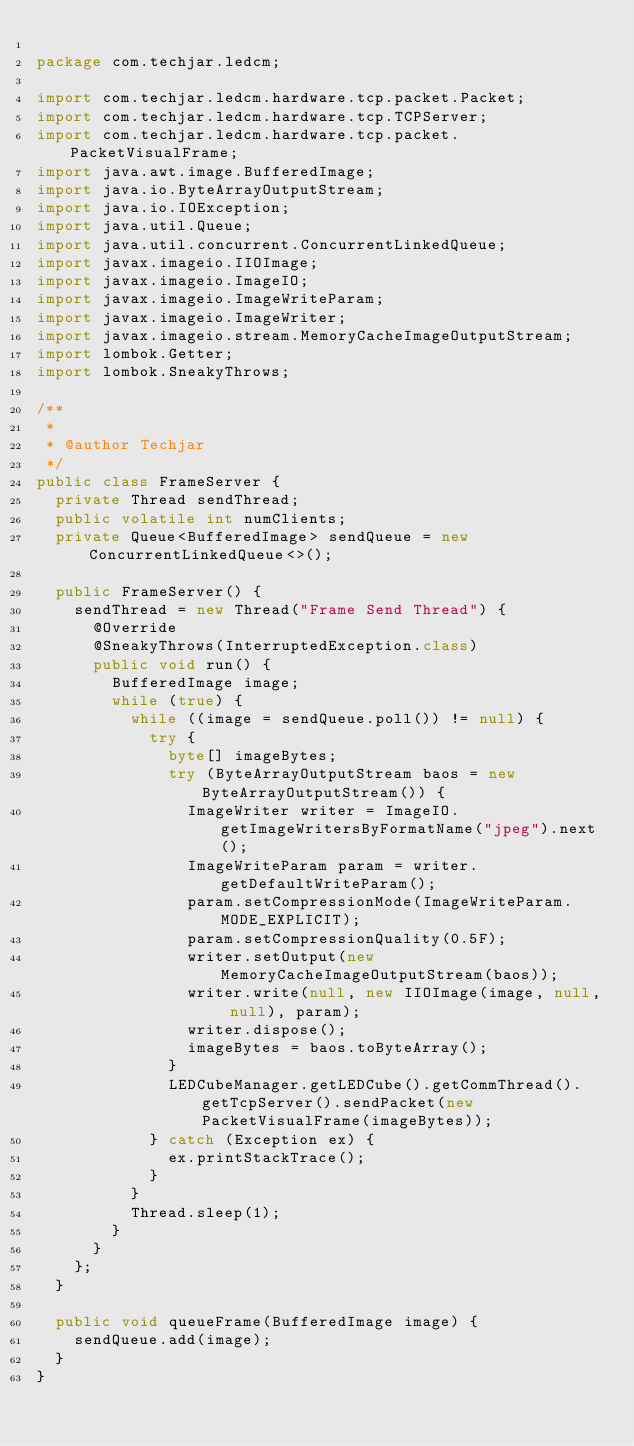Convert code to text. <code><loc_0><loc_0><loc_500><loc_500><_Java_>
package com.techjar.ledcm;

import com.techjar.ledcm.hardware.tcp.packet.Packet;
import com.techjar.ledcm.hardware.tcp.TCPServer;
import com.techjar.ledcm.hardware.tcp.packet.PacketVisualFrame;
import java.awt.image.BufferedImage;
import java.io.ByteArrayOutputStream;
import java.io.IOException;
import java.util.Queue;
import java.util.concurrent.ConcurrentLinkedQueue;
import javax.imageio.IIOImage;
import javax.imageio.ImageIO;
import javax.imageio.ImageWriteParam;
import javax.imageio.ImageWriter;
import javax.imageio.stream.MemoryCacheImageOutputStream;
import lombok.Getter;
import lombok.SneakyThrows;

/**
 *
 * @author Techjar
 */
public class FrameServer {
	private Thread sendThread;
	public volatile int numClients;
	private Queue<BufferedImage> sendQueue = new ConcurrentLinkedQueue<>();

	public FrameServer() {
		sendThread = new Thread("Frame Send Thread") {
			@Override
			@SneakyThrows(InterruptedException.class)
			public void run() {
				BufferedImage image;
				while (true) {
					while ((image = sendQueue.poll()) != null) {
						try {
							byte[] imageBytes;
							try (ByteArrayOutputStream baos = new ByteArrayOutputStream()) {
								ImageWriter writer = ImageIO.getImageWritersByFormatName("jpeg").next();
								ImageWriteParam param = writer.getDefaultWriteParam();
								param.setCompressionMode(ImageWriteParam.MODE_EXPLICIT);
								param.setCompressionQuality(0.5F);
								writer.setOutput(new MemoryCacheImageOutputStream(baos));
								writer.write(null, new IIOImage(image, null, null), param);
								writer.dispose();
								imageBytes = baos.toByteArray();
							}
							LEDCubeManager.getLEDCube().getCommThread().getTcpServer().sendPacket(new PacketVisualFrame(imageBytes));
						} catch (Exception ex) {
							ex.printStackTrace();
						}
					}
					Thread.sleep(1);
				}
			}
		};
	}

	public void queueFrame(BufferedImage image) {
		sendQueue.add(image);
	}
}
</code> 